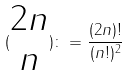<formula> <loc_0><loc_0><loc_500><loc_500>( \begin{matrix} 2 n \\ n \end{matrix} ) \colon = \frac { ( 2 n ) ! } { ( n ! ) ^ { 2 } }</formula> 